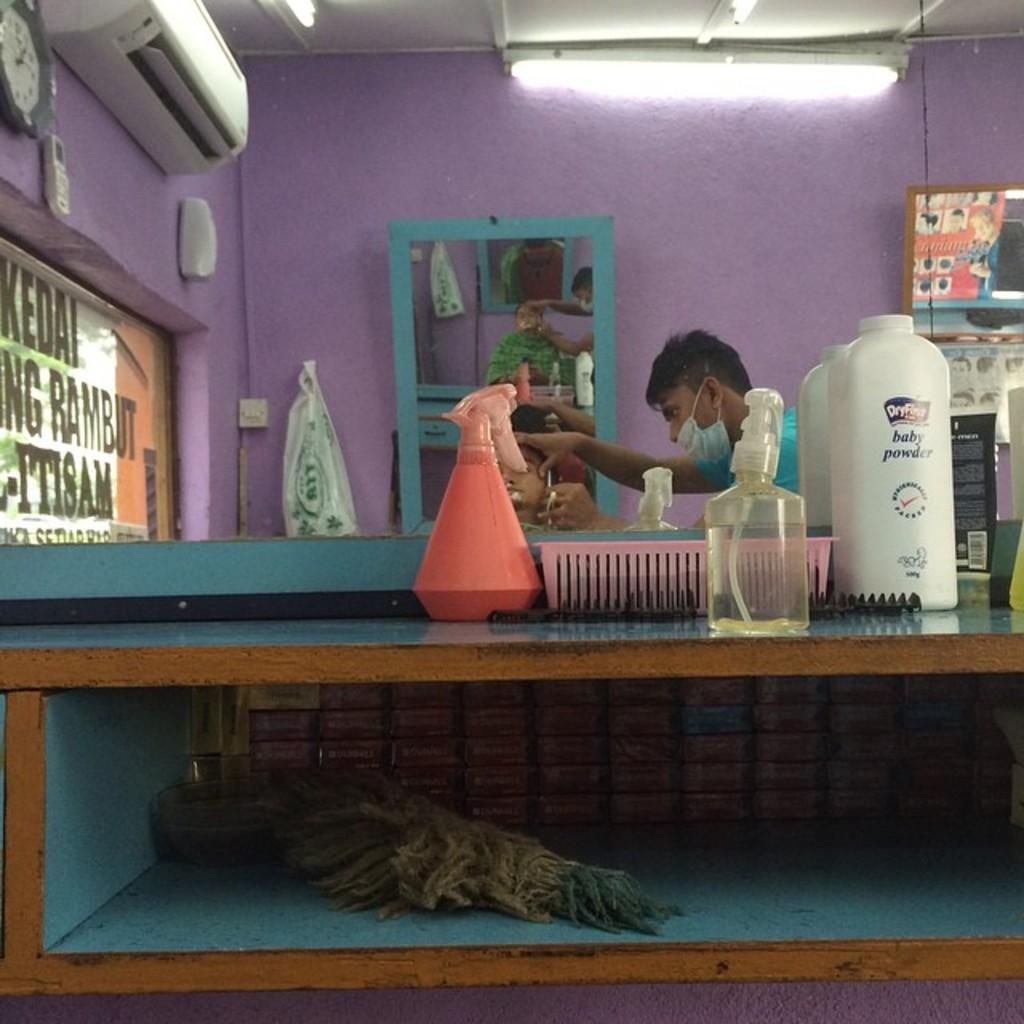In one or two sentences, can you explain what this image depicts? This picture shows a saloon where a man shaving a customer and we see a mirror and bottles on the table 